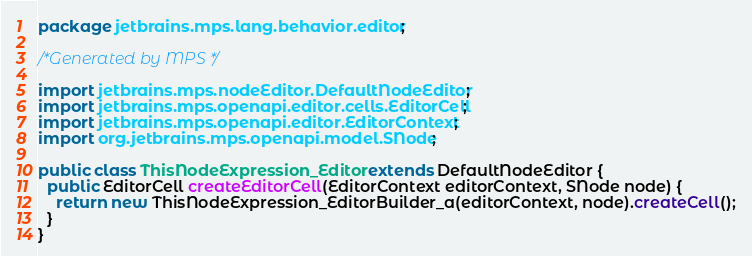<code> <loc_0><loc_0><loc_500><loc_500><_Java_>package jetbrains.mps.lang.behavior.editor;

/*Generated by MPS */

import jetbrains.mps.nodeEditor.DefaultNodeEditor;
import jetbrains.mps.openapi.editor.cells.EditorCell;
import jetbrains.mps.openapi.editor.EditorContext;
import org.jetbrains.mps.openapi.model.SNode;

public class ThisNodeExpression_Editor extends DefaultNodeEditor {
  public EditorCell createEditorCell(EditorContext editorContext, SNode node) {
    return new ThisNodeExpression_EditorBuilder_a(editorContext, node).createCell();
  }
}
</code> 